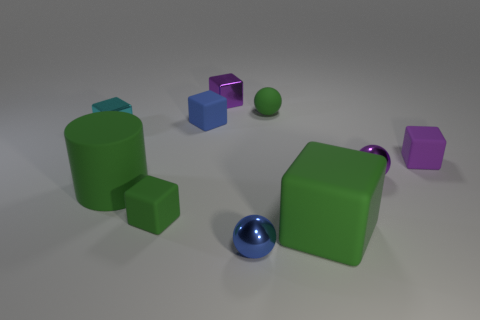What number of things are either small purple metallic cubes or small green balls?
Ensure brevity in your answer.  2. There is a blue metal object; does it have the same size as the purple block in front of the purple metal block?
Make the answer very short. Yes. There is a tiny metallic cube that is right of the cyan shiny object behind the tiny metallic thing that is in front of the cylinder; what color is it?
Offer a very short reply. Purple. What color is the rubber cylinder?
Offer a very short reply. Green. Is the number of small blocks that are behind the tiny cyan thing greater than the number of shiny balls behind the big rubber cylinder?
Ensure brevity in your answer.  Yes. There is a tiny cyan thing; is it the same shape as the tiny green rubber object that is in front of the cylinder?
Your answer should be compact. Yes. Is the size of the sphere that is behind the cyan cube the same as the blue thing in front of the large green block?
Your answer should be very brief. Yes. There is a green block that is right of the green object that is behind the cyan thing; are there any tiny blue cubes that are to the right of it?
Your answer should be compact. No. Are there fewer tiny green matte cubes that are behind the small matte ball than large blocks that are to the left of the blue matte thing?
Your answer should be compact. No. There is a purple object that is the same material as the large cylinder; what is its shape?
Make the answer very short. Cube. 